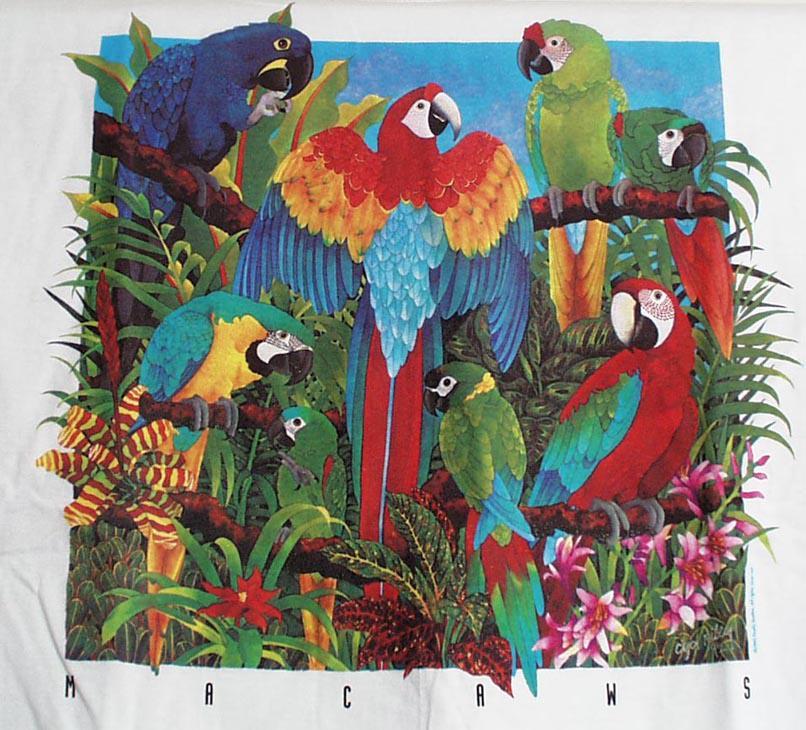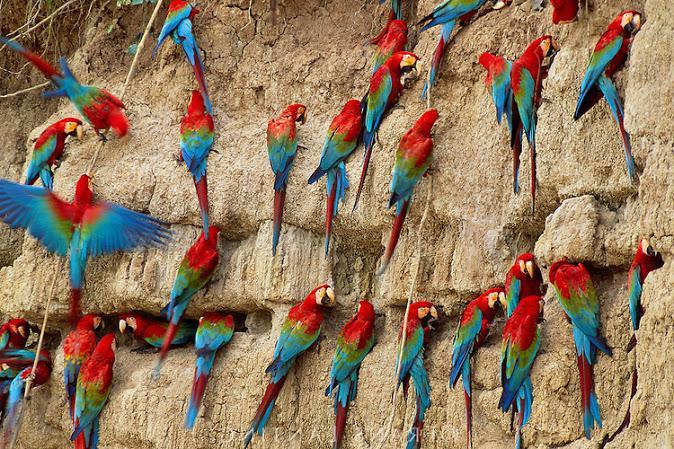The first image is the image on the left, the second image is the image on the right. Analyze the images presented: Is the assertion "The birds on the right are blue, green and orange." valid? Answer yes or no. No. 